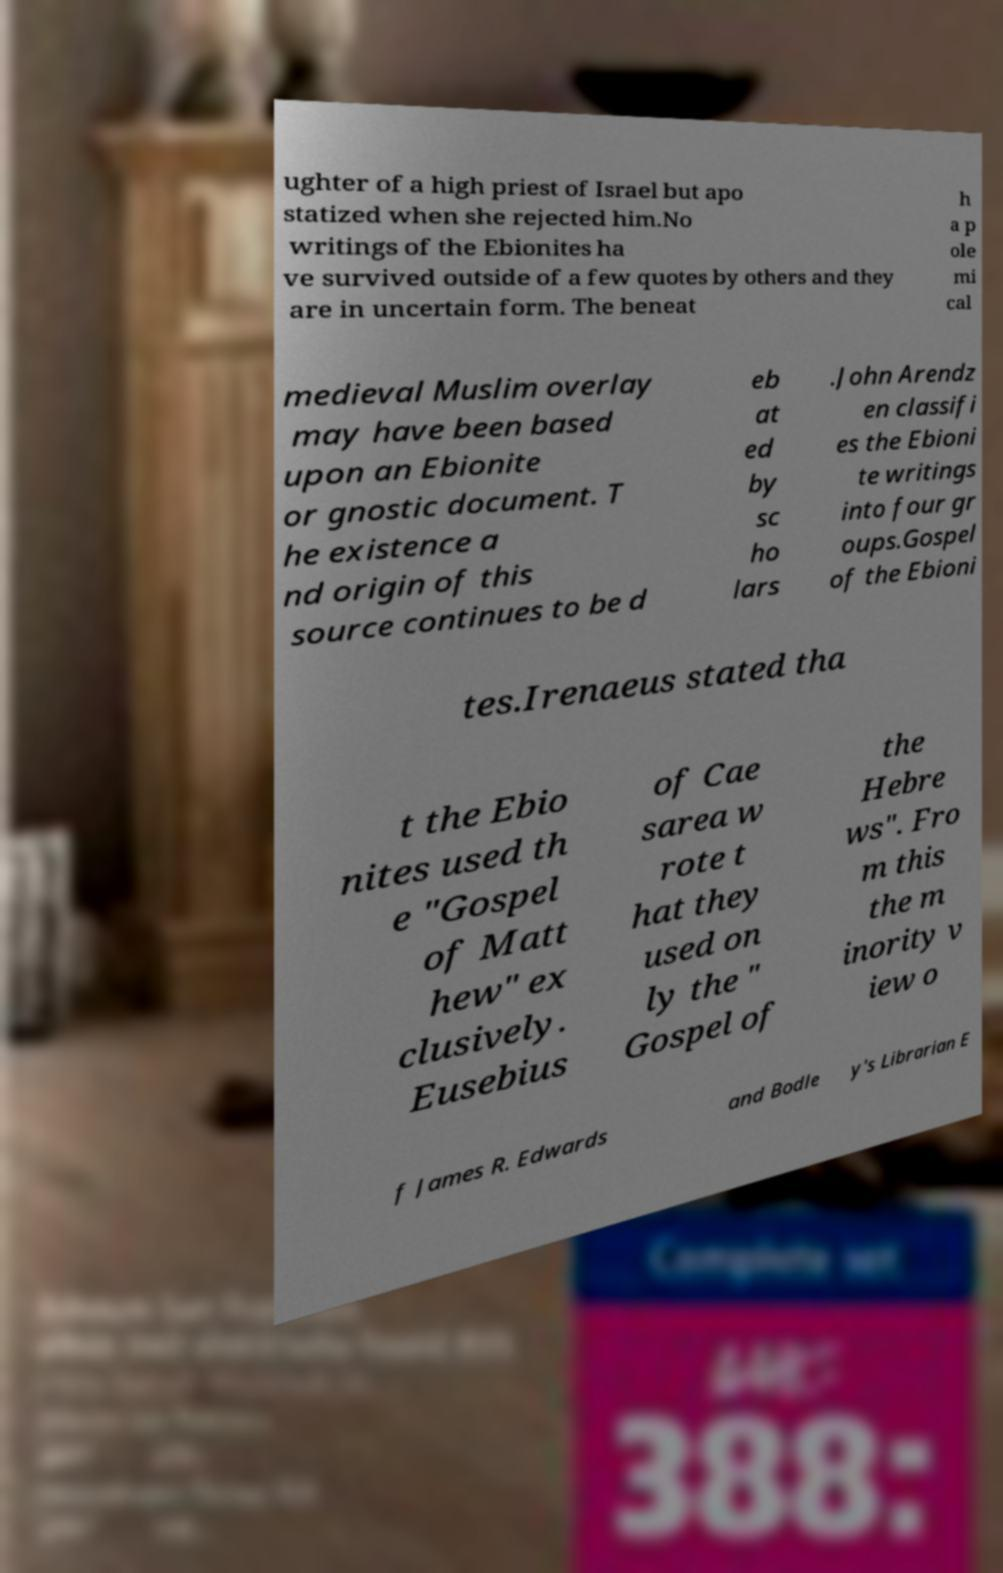There's text embedded in this image that I need extracted. Can you transcribe it verbatim? ughter of a high priest of Israel but apo statized when she rejected him.No writings of the Ebionites ha ve survived outside of a few quotes by others and they are in uncertain form. The beneat h a p ole mi cal medieval Muslim overlay may have been based upon an Ebionite or gnostic document. T he existence a nd origin of this source continues to be d eb at ed by sc ho lars .John Arendz en classifi es the Ebioni te writings into four gr oups.Gospel of the Ebioni tes.Irenaeus stated tha t the Ebio nites used th e "Gospel of Matt hew" ex clusively. Eusebius of Cae sarea w rote t hat they used on ly the " Gospel of the Hebre ws". Fro m this the m inority v iew o f James R. Edwards and Bodle y's Librarian E 